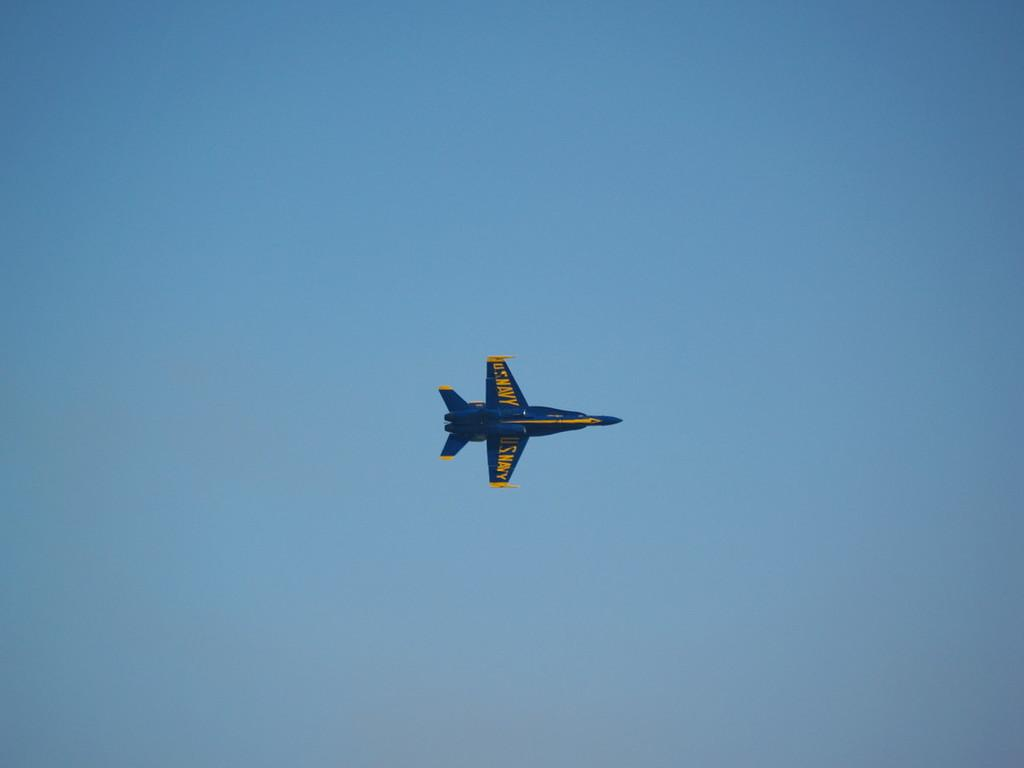What is the main subject of the image? The main subject of the image is a jet plane. Can you describe the location of the jet plane in the image? The jet plane is in the air. How many nations can be seen kissing in the image? There are no nations or kissing depicted in the image; it features a jet plane in the air. What type of growth can be observed on the wings of the jet plane in the image? There is no growth visible on the wings of the jet plane in the image. 